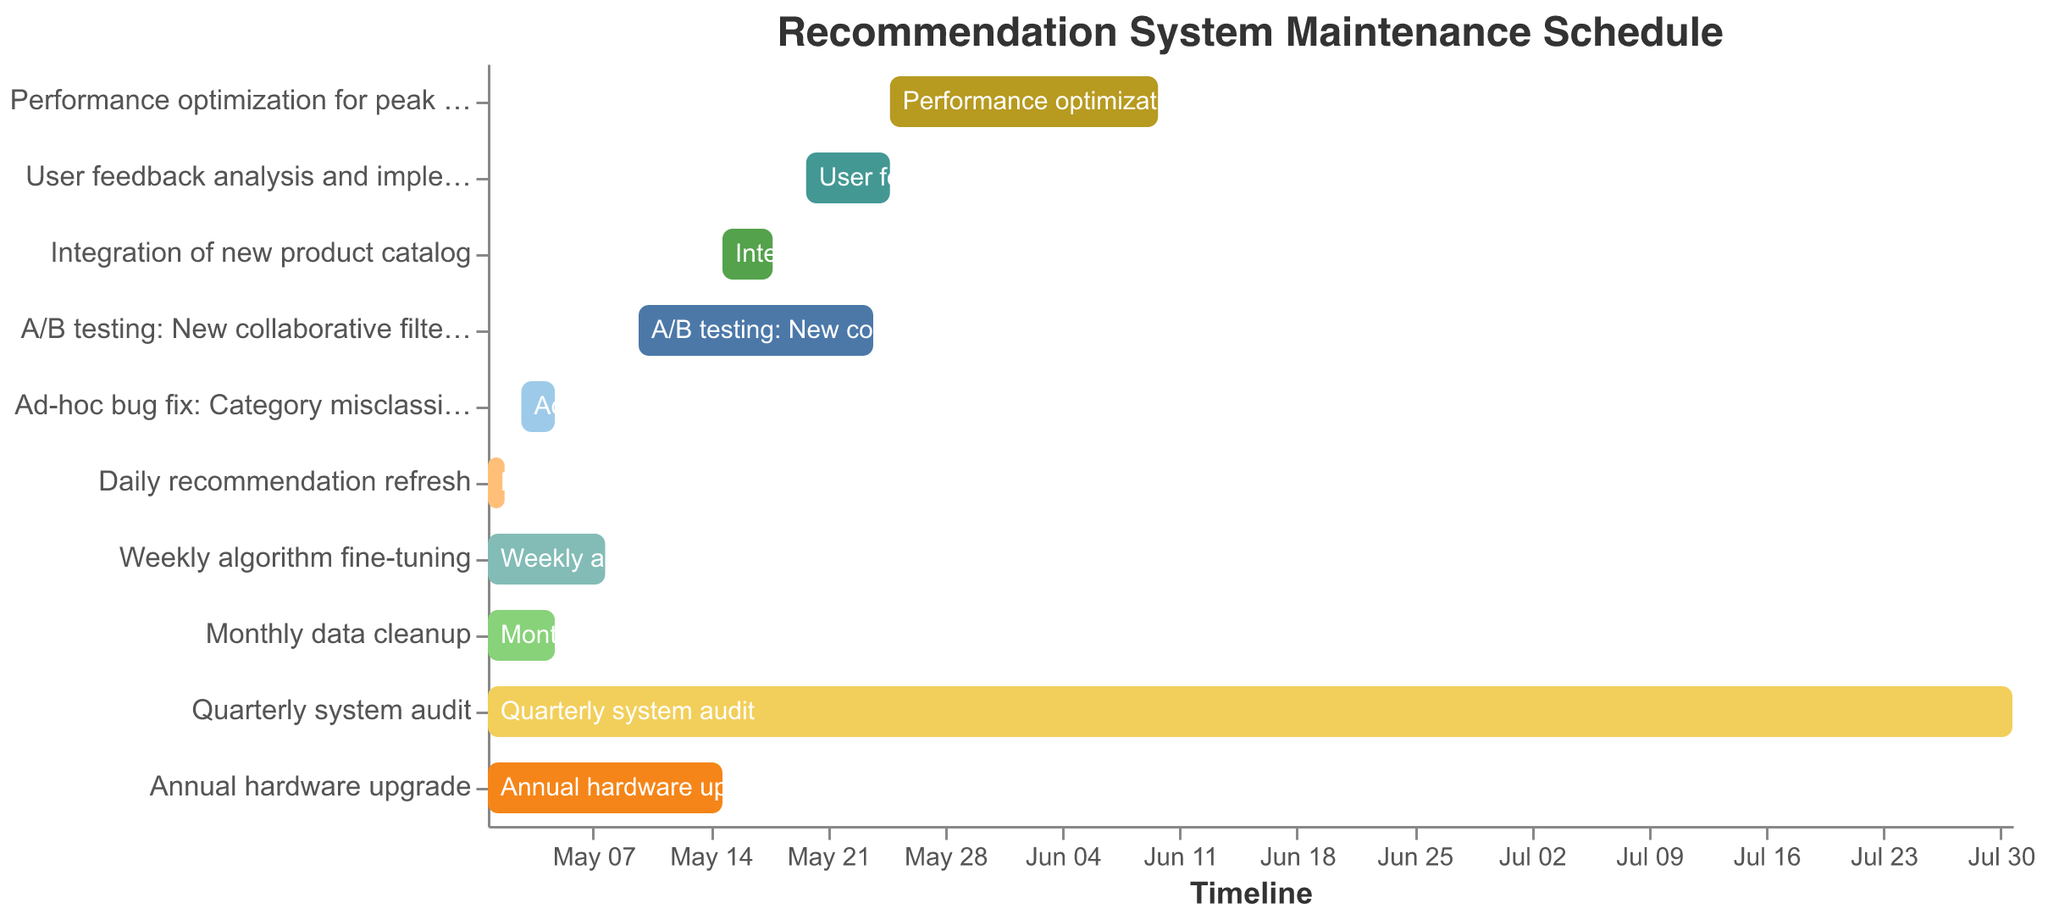What is the duration of the Quarterly system audit? The start date for the Quarterly system audit is 2023-05-01 and the end date is 2023-07-31. To find the duration, compute the difference between these dates. The Quarterly system audit lasts from May 1 to July 31, which is 3 months.
Answer: 3 months Which maintenance task has the shortest duration? To find the shortest duration, we need to look at the start and end dates for each task. The Daily recommendation refresh task starts on 2023-05-01 and ends on 2023-05-02, making it the shortest task at 1 day.
Answer: Daily recommendation refresh How many tasks are scheduled to start in May 2023? To answer this, we need to count the tasks with a start date in May 2023. There are 10 tasks: Daily recommendation refresh, Weekly algorithm fine-tuning, Monthly data cleanup, Quarterly system audit, Annual hardware upgrade, Ad-hoc bug fix: Category misclassification, A/B testing: New collaborative filtering approach, Integration of new product catalog, User feedback analysis and implementation, and Performance optimization for peak shopping season.
Answer: 10 Which tasks overlap with the Annual hardware upgrade? The Annual hardware upgrade starts on 2023-05-01 and ends on 2023-05-15. We need to find tasks whose start or end dates fall within this period. The overlapping tasks are: Daily recommendation refresh, Weekly algorithm fine-tuning, Monthly data cleanup, Quarterly system audit, Ad-hoc bug fix: Category misclassification, and A/B testing: New collaborative filtering approach.
Answer: Daily recommendation refresh, Weekly algorithm fine-tuning, Monthly data cleanup, Quarterly system audit, Ad-hoc bug fix: Category misclassification, A/B testing: New collaborative filtering approach Which task ends at the latest date? To find the task that ends last, look at the end dates for all tasks. The Quarterly system audit ends on 2023-07-31, which is the latest date among all tasks.
Answer: Quarterly system audit How many days does the A/B testing: New collaborative filtering approach span? The A/B testing starts on 2023-05-10 and ends on 2023-05-24. To find the number of days, calculate the difference between these dates. The duration is 15 days.
Answer: 15 days What tasks are scheduled after the Monthly data cleanup ends? The Monthly data cleanup ends on 2023-05-05. We need to find tasks that are scheduled to start after this date. The tasks are: A/B testing: New collaborative filtering approach (2023-05-10), Integration of new product catalog (2023-05-15), User feedback analysis and implementation (2023-05-20), and Performance optimization for peak shopping season (2023-05-25).
Answer: A/B testing: New collaborative filtering approach, Integration of new product catalog, User feedback analysis and implementation, Performance optimization for peak shopping season 